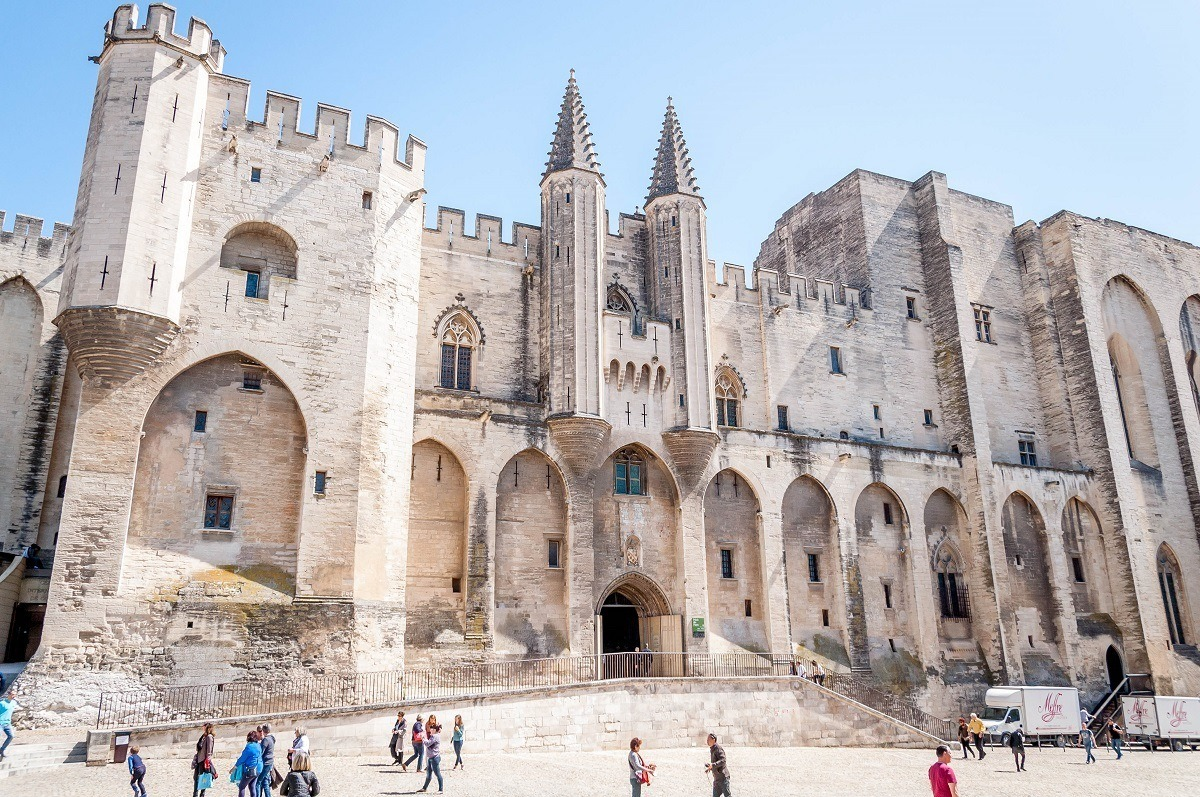Imagine the life of people during the time this palace was actively used. During the time the Papal Palace was actively used, it bustled with activity as the administrative and religious center of the Papacy when the Popes resided in Avignon. The grand halls would have witnessed gatherings of high-ranking clergy, diplomats from all over Europe, and various officials managing the vast interests of the Church. Monks and scribes might have been seen walking through the corridors, engrossed in religious and administrative duties. The surrounding areas would likely have been lively with traders, pilgrims, and local residents, each contributing to the dynamic environment. The air would have been filled with the sounds of church bells, the chanting of prayers, and the bustling of daily medieval life. 